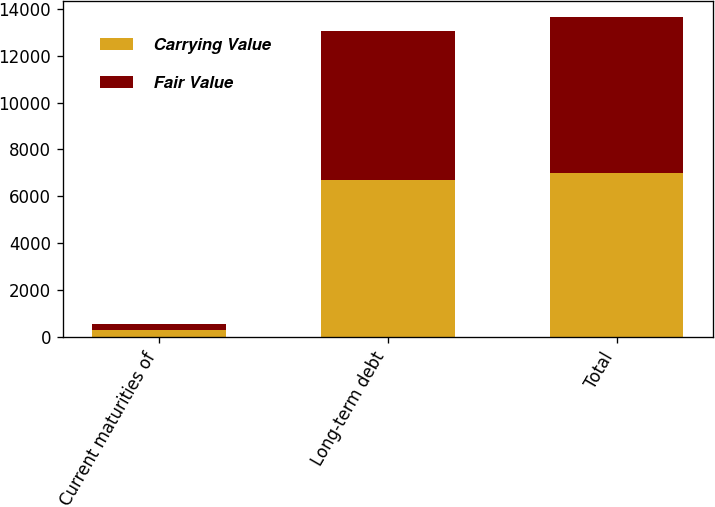Convert chart. <chart><loc_0><loc_0><loc_500><loc_500><stacked_bar_chart><ecel><fcel>Current maturities of<fcel>Long-term debt<fcel>Total<nl><fcel>Carrying Value<fcel>289<fcel>6715<fcel>7004<nl><fcel>Fair Value<fcel>289<fcel>6330<fcel>6619<nl></chart> 